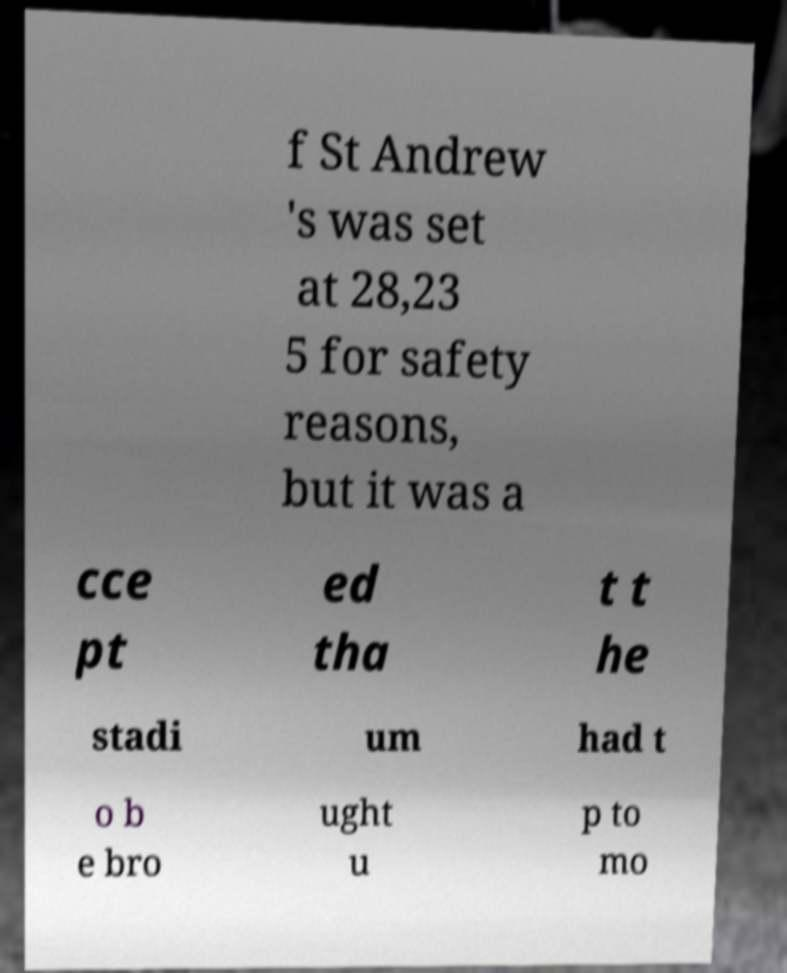Can you accurately transcribe the text from the provided image for me? f St Andrew 's was set at 28,23 5 for safety reasons, but it was a cce pt ed tha t t he stadi um had t o b e bro ught u p to mo 